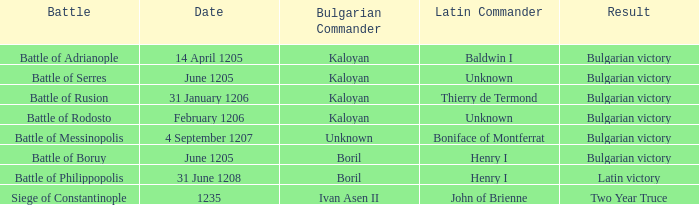On which date did henry i become the latin commander in the battle of boruy? June 1205. Parse the full table. {'header': ['Battle', 'Date', 'Bulgarian Commander', 'Latin Commander', 'Result'], 'rows': [['Battle of Adrianople', '14 April 1205', 'Kaloyan', 'Baldwin I', 'Bulgarian victory'], ['Battle of Serres', 'June 1205', 'Kaloyan', 'Unknown', 'Bulgarian victory'], ['Battle of Rusion', '31 January 1206', 'Kaloyan', 'Thierry de Termond', 'Bulgarian victory'], ['Battle of Rodosto', 'February 1206', 'Kaloyan', 'Unknown', 'Bulgarian victory'], ['Battle of Messinopolis', '4 September 1207', 'Unknown', 'Boniface of Montferrat', 'Bulgarian victory'], ['Battle of Boruy', 'June 1205', 'Boril', 'Henry I', 'Bulgarian victory'], ['Battle of Philippopolis', '31 June 1208', 'Boril', 'Henry I', 'Latin victory'], ['Siege of Constantinople', '1235', 'Ivan Asen II', 'John of Brienne', 'Two Year Truce']]} 